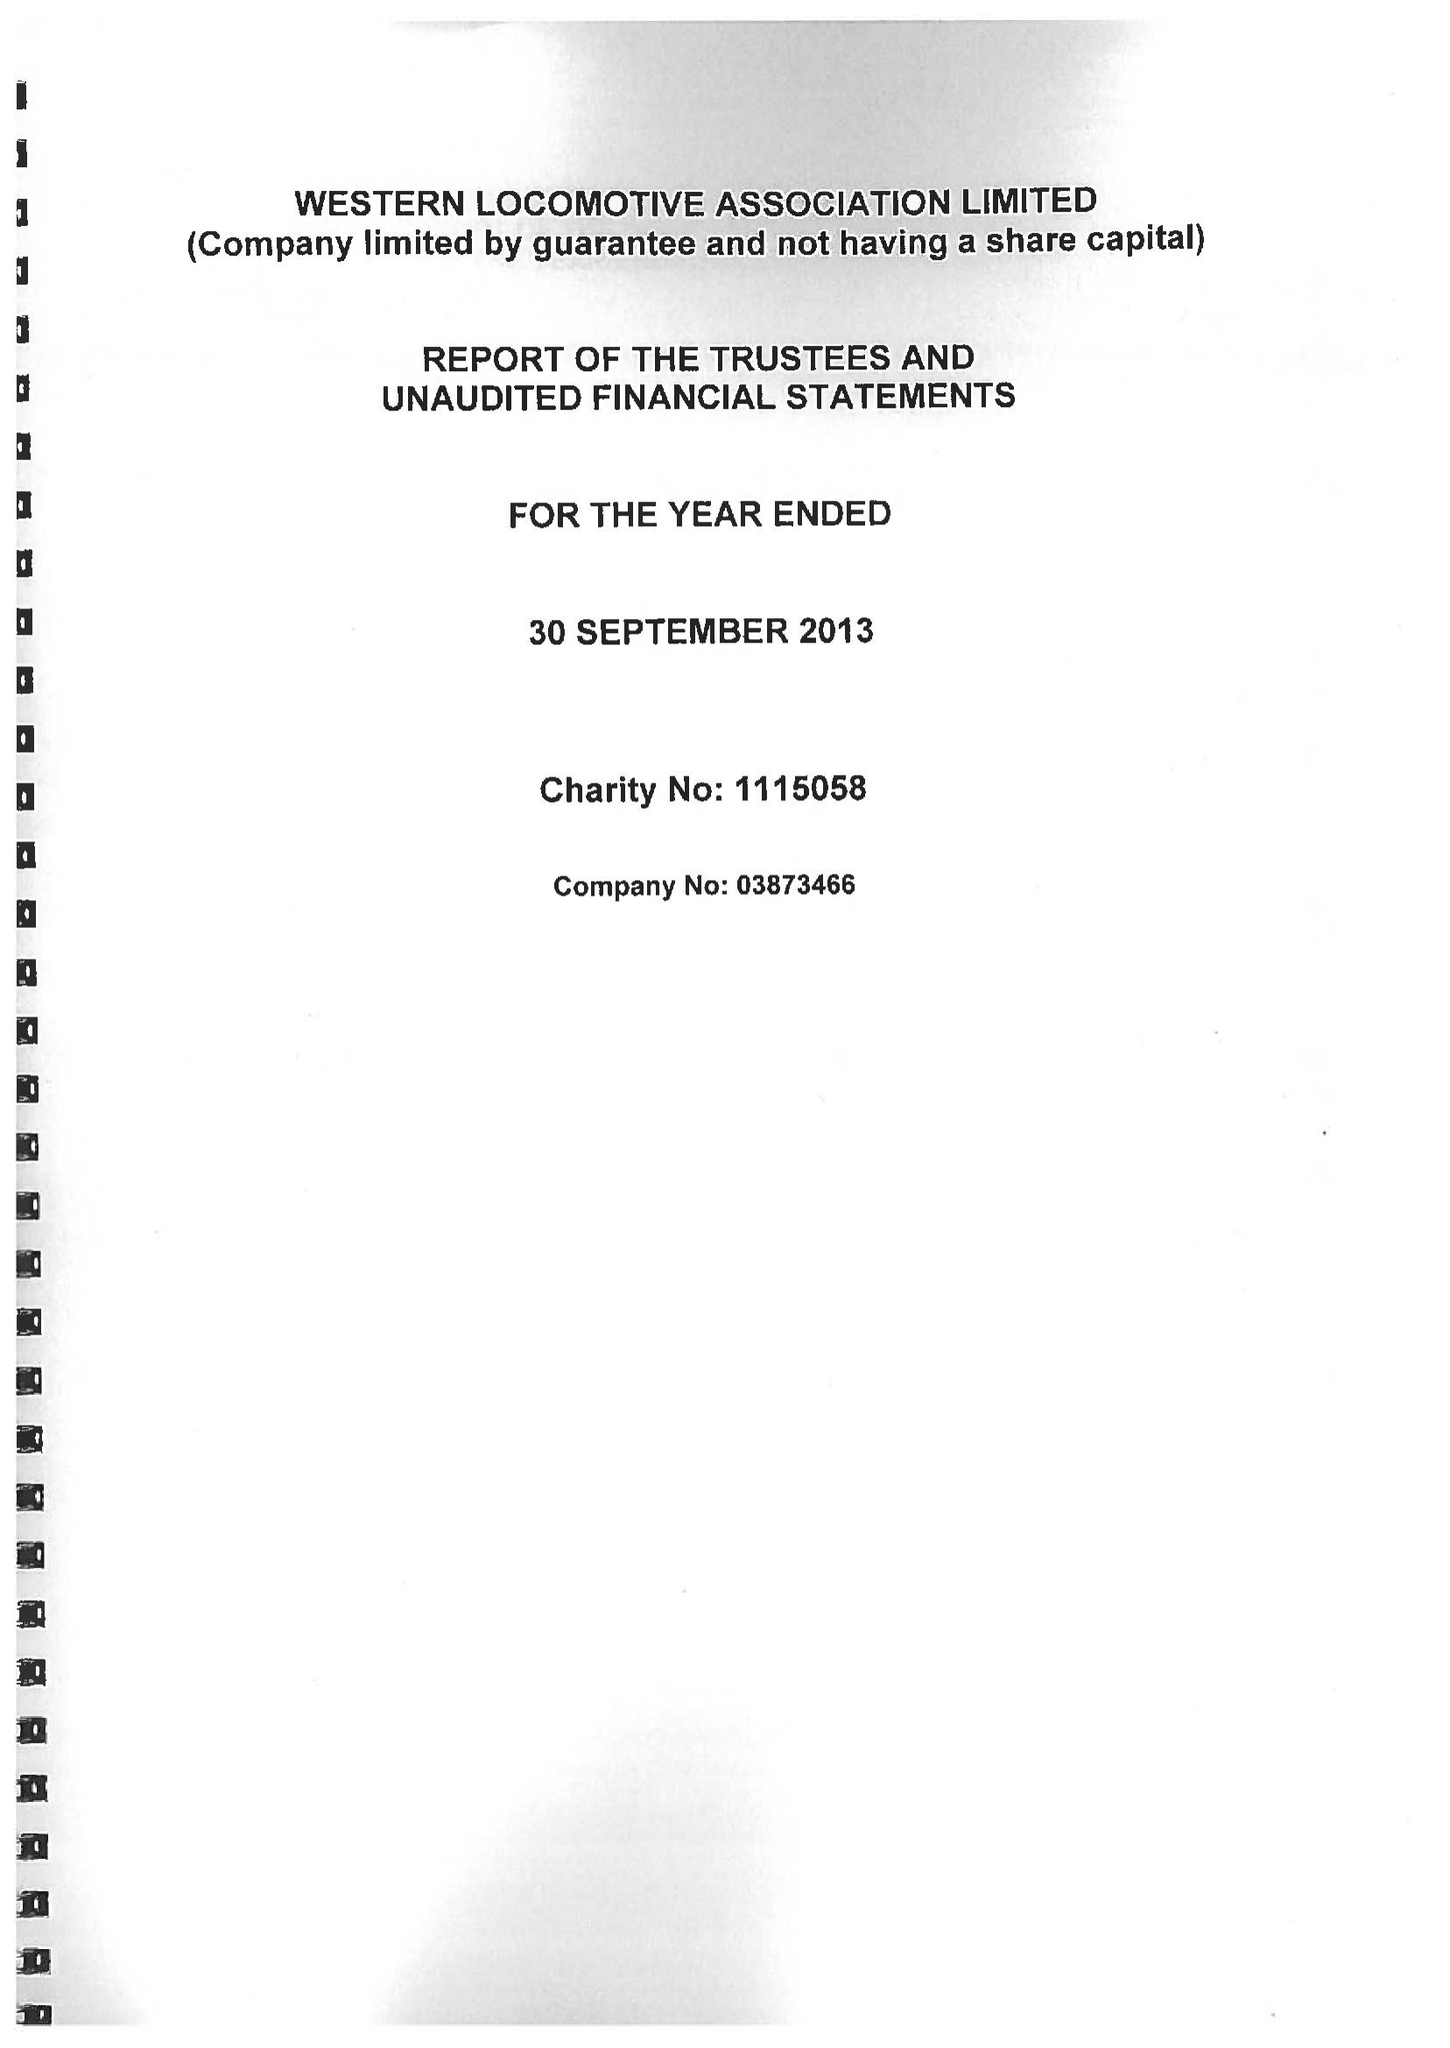What is the value for the charity_number?
Answer the question using a single word or phrase. 1115058 